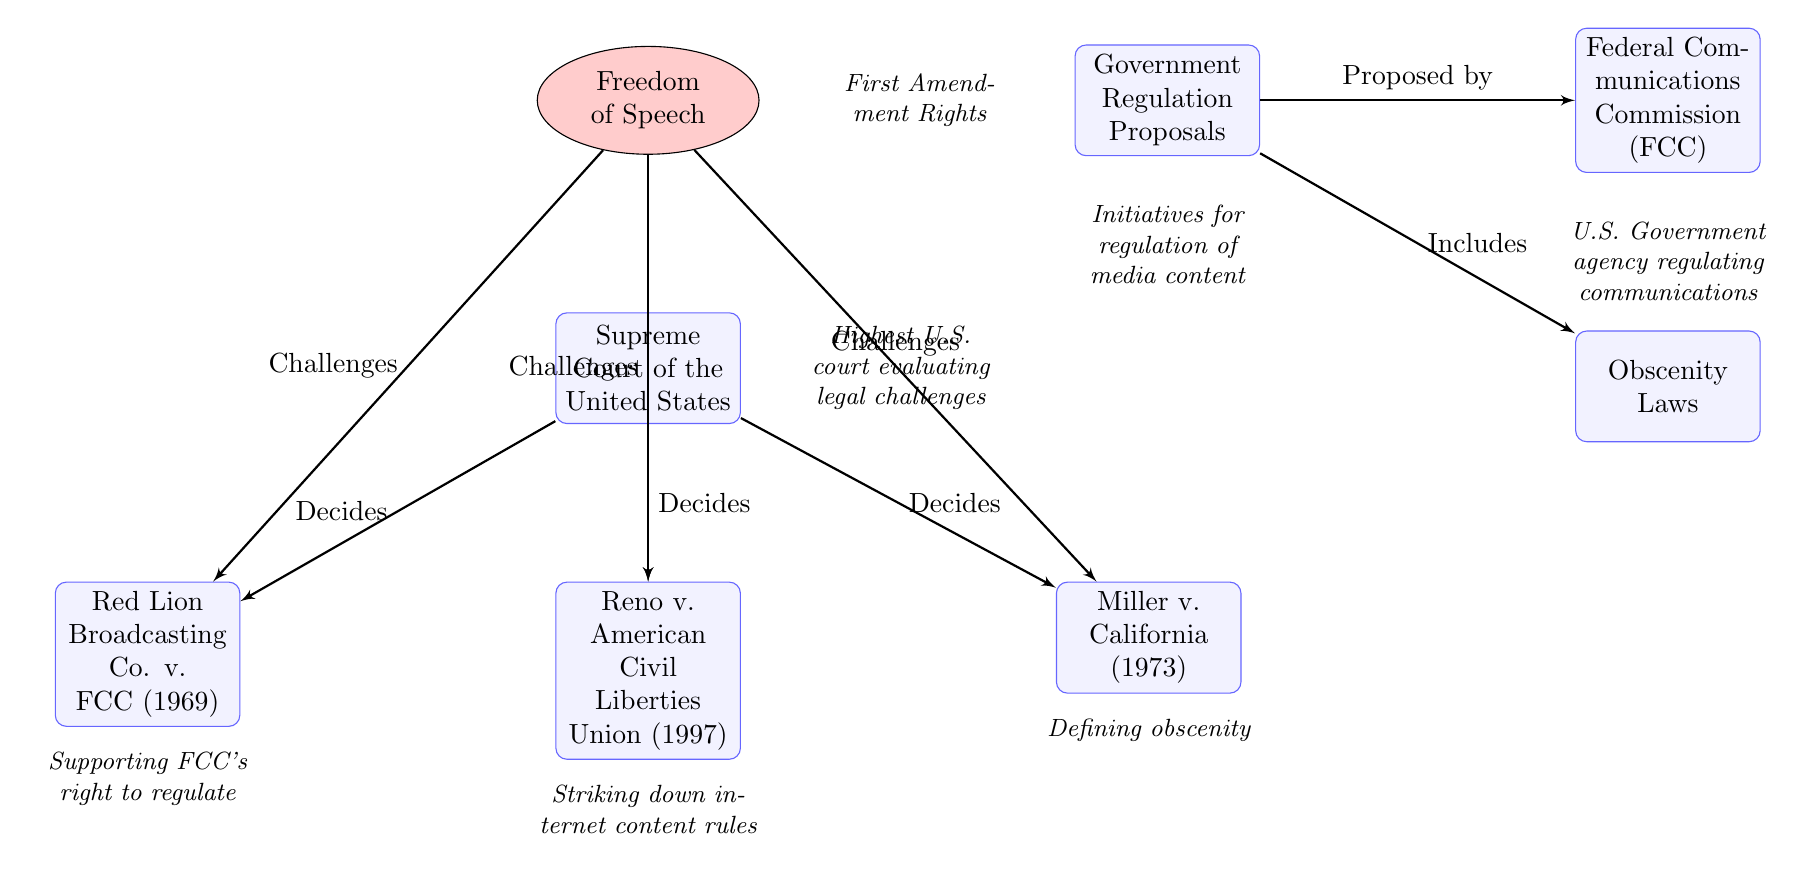What are the two main nodes on the left side of the diagram? The left side of the diagram features the nodes labeled "Freedom of Speech" and "Government Regulation Proposals." These are the primary areas representing the conflict between free speech and regulatory pressures in the media context.
Answer: Freedom of Speech, Government Regulation Proposals Which court is involved in deciding the legal challenges related to media regulations? In the diagram, the node labeled "Supreme Court of the United States" is directly connected to the challenges regarding media regulations, indicating its role in making decisions about cases involving free speech and government control.
Answer: Supreme Court of the United States How many notable cases are referenced in the diagram? There are three specific cases mentioned: Red Lion Broadcasting Co. v. FCC, Reno v. American Civil Liberties Union, and Miller v. California, resulting in a total of three notable cases.
Answer: 3 What did the case Reno v. American Civil Liberties Union achieve according to the diagram? The diagram indicates that the Reno case is associated with "Striking down internet content rules," highlighting the court's action against certain regulations on internet content.
Answer: Striking down internet content rules What relationship exists between Government Regulation Proposals and the Federal Communications Commission (FCC)? The diagram indicates a directional flow from "Government Regulation Proposals" to the "Federal Communications Commission (FCC)," describing that these proposals are put forward by or derived from the FCC, which is responsible for regulating communications in the U.S.
Answer: Proposed by Which landmark case supports the FCC's right to regulate according to the diagram? The diagram connects "Red Lion Broadcasting Co. v. FCC" to the Supreme Court decision-making process, denoting that this case supports the FCC's authority to regulate media.
Answer: Red Lion Broadcasting Co. v. FCC What key aspect of obscenity is defined in Miller v. California? The diagram classifies Miller v. California with the description "Defining obscenity," which reveals that this case addresses the legal standards surrounding obscenity in media content.
Answer: Defining obscenity How does Freedom of Speech relate to the cases listed below it? The diagram shows a pathway from "Freedom of Speech" to the three cases (Red Lion, Reno, and Miller), indicating that these cases challenge or engage with the issues surrounding free speech as it relates to media content regulation.
Answer: Challenges What additional information does the diagram provide under the Federal Communications Commission (FCC) node? The diagram notes that the FCC is described as "U.S. Government agency regulating communications," providing context on its role and function within the framework of media regulation.
Answer: U.S. Government agency regulating communications 